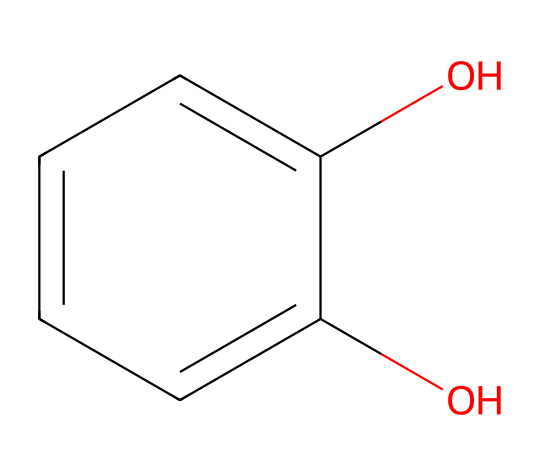What is the name of this chemical? The molecular structure corresponds to catechol, which is a dihydroxybenzene where two hydroxyl groups are attached to a benzene ring.
Answer: catechol How many hydroxyl groups are present in catechol? The structure shows two -OH groups (hydroxyl groups) attached to the benzene ring, indicating the presence of two functionalities.
Answer: two What is the primary functional group in catechol? The presence of -OH groups indicates that catechol features hydroxyl groups as its primary functional features, characteristic of phenolic compounds.
Answer: hydroxyl How many carbon atoms are in catechol? In the structure, there are six carbon atoms present in the benzene ring, which is characteristic of the phenolic compound catechol.
Answer: six What type of compound is catechol classified as? Catechol is classified as a phenol due to the presence of a hydroxyl group directly attached to an aromatic benzene ring, which is the defining feature of phenolic compounds.
Answer: phenol How does catechol's structure affect its activity as a reducing agent in photographic processes? Catechol, with its adjacent hydroxyl groups, can readily donate electrons, which enhances its reducing properties, making it effective in photographic development processes.
Answer: promoting reducing activity What distinguishes catechol from other phenols? The specific position of the hydroxyl groups on the benzene ring (1,2-positions) distinguishes catechol, as it is a ortho-dihydroxybenzene, affecting its chemical reactivity compared to other phenols.
Answer: ortho-dihydroxybenzene 